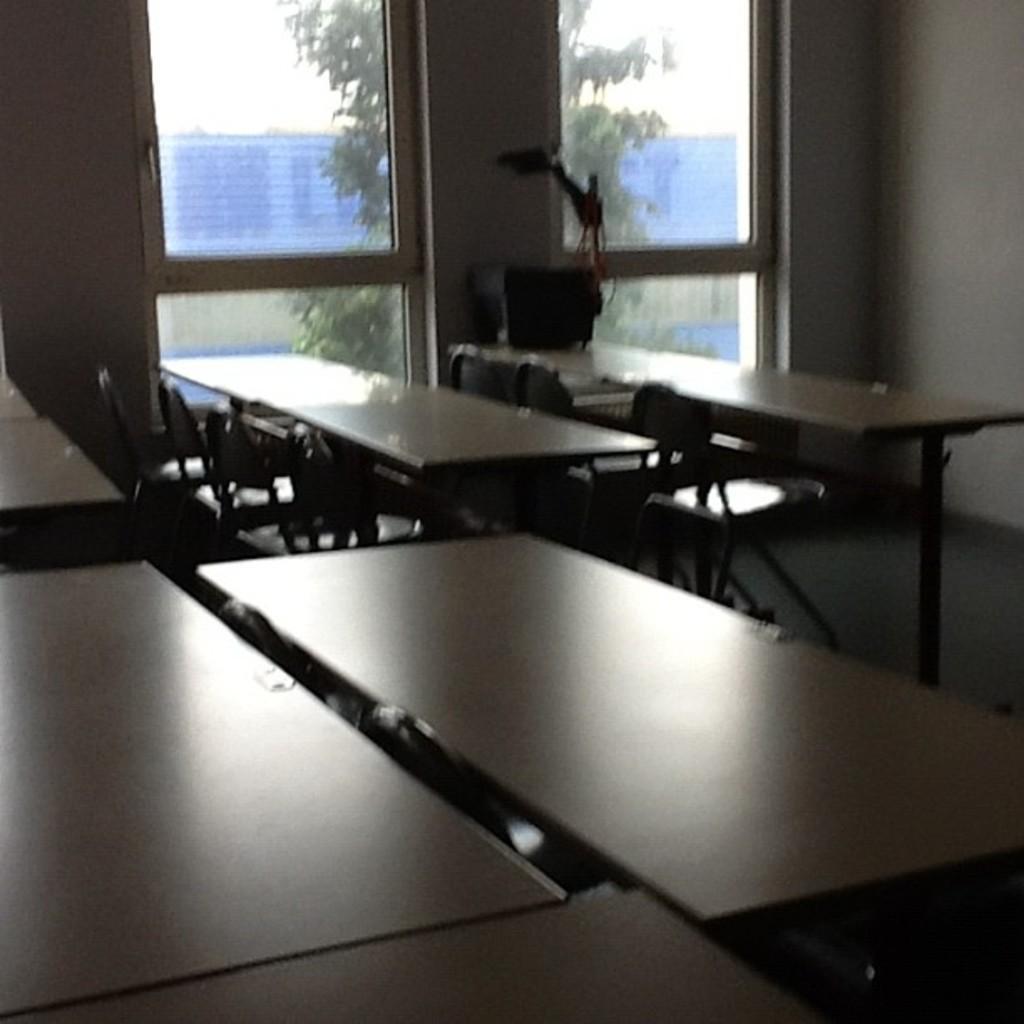Please provide a concise description of this image. This is an inside view. Here I can see tables and chairs on the floor. In the background there are two windows to the wall. Through the windows we can see the outside view. In the outside there is a tree and a building. 